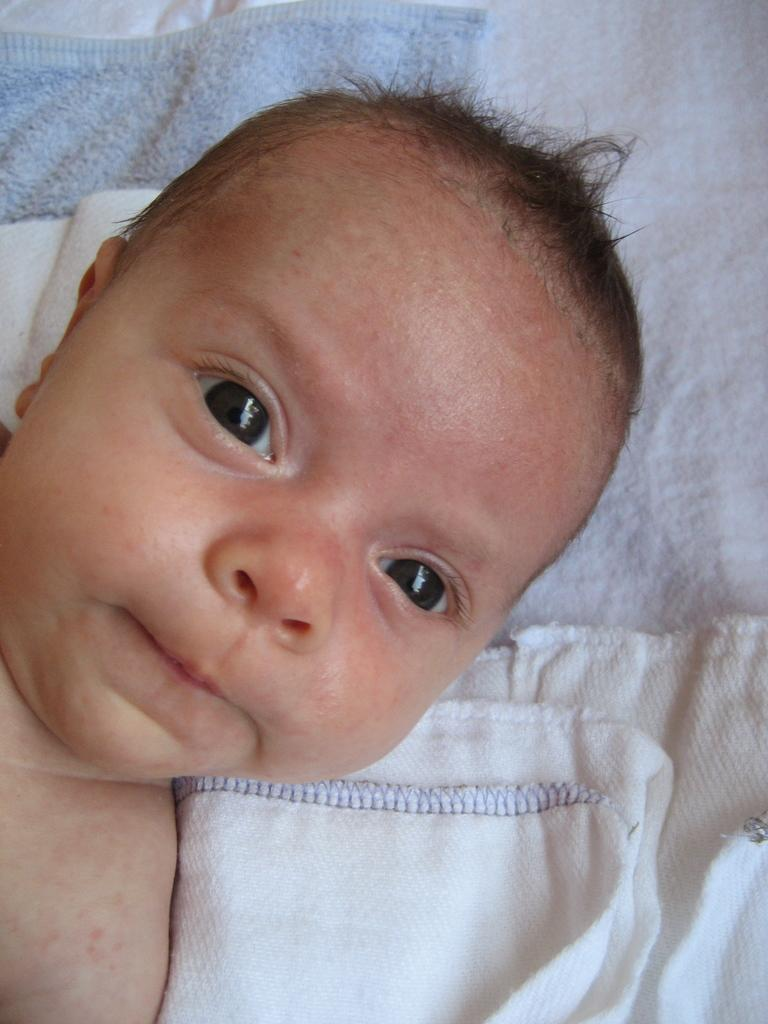What is the main subject of the image? There is a baby in the image. What color is the towel in the image? There is a blue towel in the image. What color is the napkin in the image? There is a white napkin in the image. What type of book is the baby reading in the image? There is no book or reading activity present in the image. 